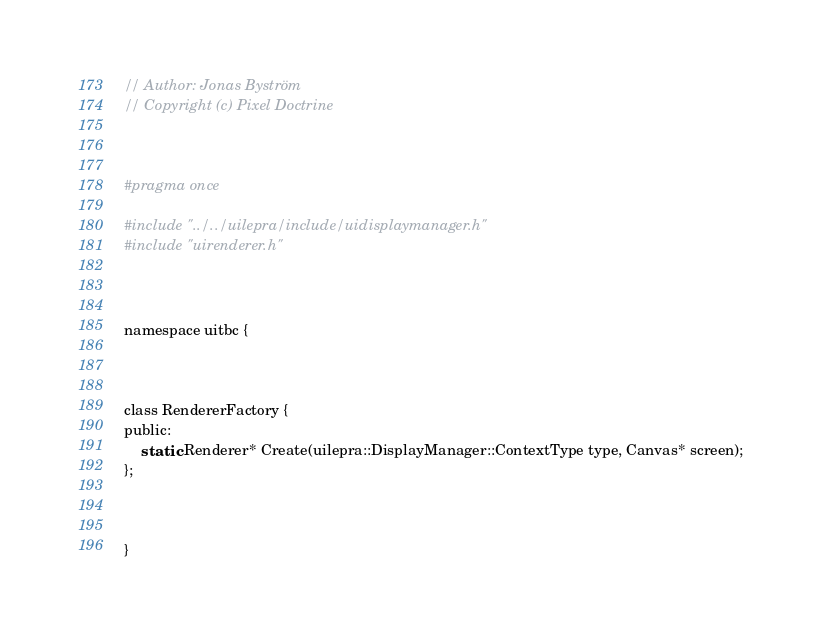Convert code to text. <code><loc_0><loc_0><loc_500><loc_500><_C_>
// Author: Jonas Byström
// Copyright (c) Pixel Doctrine



#pragma once

#include "../../uilepra/include/uidisplaymanager.h"
#include "uirenderer.h"



namespace uitbc {



class RendererFactory {
public:
	static Renderer* Create(uilepra::DisplayManager::ContextType type, Canvas* screen);
};



}
</code> 